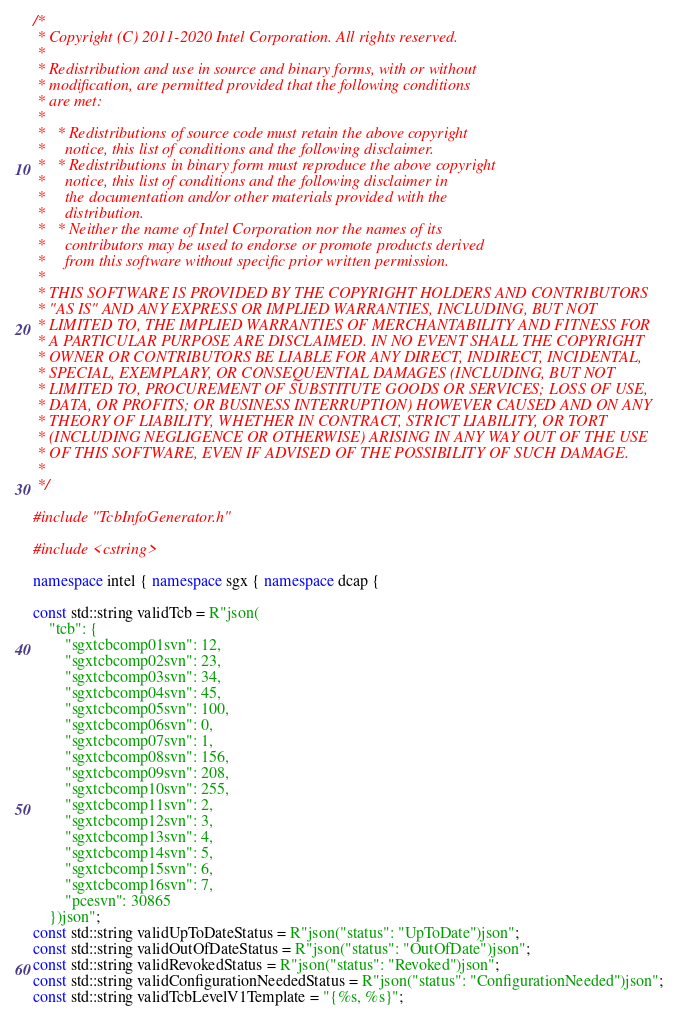Convert code to text. <code><loc_0><loc_0><loc_500><loc_500><_C++_>/*
 * Copyright (C) 2011-2020 Intel Corporation. All rights reserved.
 *
 * Redistribution and use in source and binary forms, with or without
 * modification, are permitted provided that the following conditions
 * are met:
 *
 *   * Redistributions of source code must retain the above copyright
 *     notice, this list of conditions and the following disclaimer.
 *   * Redistributions in binary form must reproduce the above copyright
 *     notice, this list of conditions and the following disclaimer in
 *     the documentation and/or other materials provided with the
 *     distribution.
 *   * Neither the name of Intel Corporation nor the names of its
 *     contributors may be used to endorse or promote products derived
 *     from this software without specific prior written permission.
 *
 * THIS SOFTWARE IS PROVIDED BY THE COPYRIGHT HOLDERS AND CONTRIBUTORS
 * "AS IS" AND ANY EXPRESS OR IMPLIED WARRANTIES, INCLUDING, BUT NOT
 * LIMITED TO, THE IMPLIED WARRANTIES OF MERCHANTABILITY AND FITNESS FOR
 * A PARTICULAR PURPOSE ARE DISCLAIMED. IN NO EVENT SHALL THE COPYRIGHT
 * OWNER OR CONTRIBUTORS BE LIABLE FOR ANY DIRECT, INDIRECT, INCIDENTAL,
 * SPECIAL, EXEMPLARY, OR CONSEQUENTIAL DAMAGES (INCLUDING, BUT NOT
 * LIMITED TO, PROCUREMENT OF SUBSTITUTE GOODS OR SERVICES; LOSS OF USE,
 * DATA, OR PROFITS; OR BUSINESS INTERRUPTION) HOWEVER CAUSED AND ON ANY
 * THEORY OF LIABILITY, WHETHER IN CONTRACT, STRICT LIABILITY, OR TORT
 * (INCLUDING NEGLIGENCE OR OTHERWISE) ARISING IN ANY WAY OUT OF THE USE
 * OF THIS SOFTWARE, EVEN IF ADVISED OF THE POSSIBILITY OF SUCH DAMAGE.
 *
 */

#include "TcbInfoGenerator.h"

#include <cstring>

namespace intel { namespace sgx { namespace dcap {

const std::string validTcb = R"json(
    "tcb": {
        "sgxtcbcomp01svn": 12,
        "sgxtcbcomp02svn": 23,
        "sgxtcbcomp03svn": 34,
        "sgxtcbcomp04svn": 45,
        "sgxtcbcomp05svn": 100,
        "sgxtcbcomp06svn": 0,
        "sgxtcbcomp07svn": 1,
        "sgxtcbcomp08svn": 156,
        "sgxtcbcomp09svn": 208,
        "sgxtcbcomp10svn": 255,
        "sgxtcbcomp11svn": 2,
        "sgxtcbcomp12svn": 3,
        "sgxtcbcomp13svn": 4,
        "sgxtcbcomp14svn": 5,
        "sgxtcbcomp15svn": 6,
        "sgxtcbcomp16svn": 7,
        "pcesvn": 30865
    })json";
const std::string validUpToDateStatus = R"json("status": "UpToDate")json";
const std::string validOutOfDateStatus = R"json("status": "OutOfDate")json";
const std::string validRevokedStatus = R"json("status": "Revoked")json";
const std::string validConfigurationNeededStatus = R"json("status": "ConfigurationNeeded")json";
const std::string validTcbLevelV1Template = "{%s, %s}";</code> 